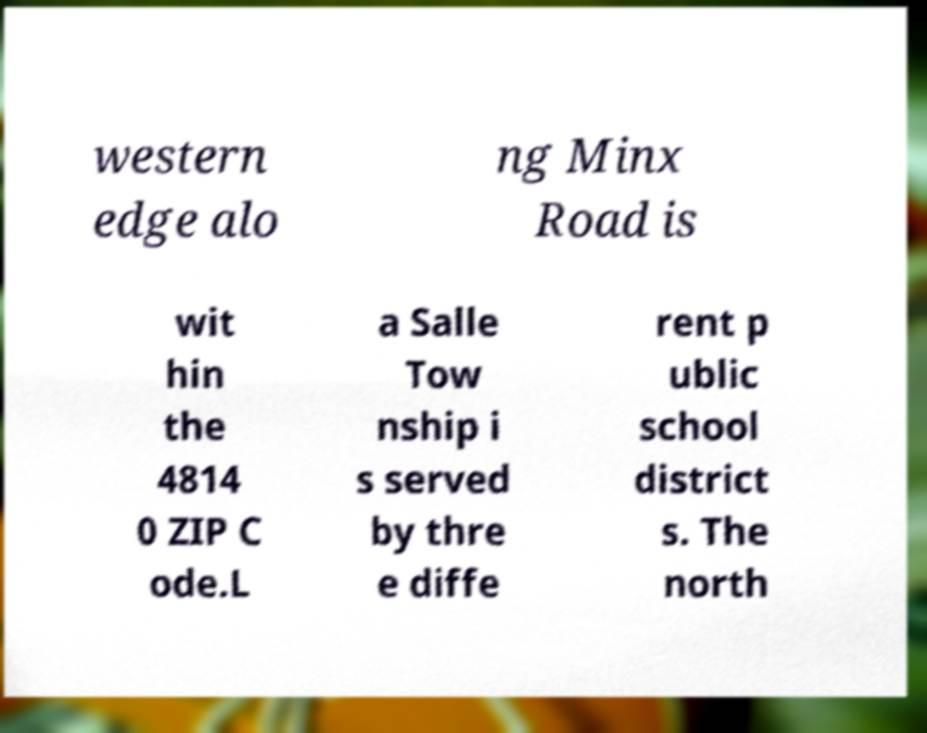Can you read and provide the text displayed in the image?This photo seems to have some interesting text. Can you extract and type it out for me? western edge alo ng Minx Road is wit hin the 4814 0 ZIP C ode.L a Salle Tow nship i s served by thre e diffe rent p ublic school district s. The north 